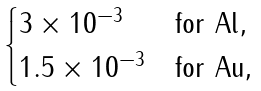Convert formula to latex. <formula><loc_0><loc_0><loc_500><loc_500>\begin{cases} 3 \times 1 0 ^ { - 3 } & \text {for Al} , \\ 1 . 5 \times 1 0 ^ { - 3 } & \text {for Au} , \end{cases}</formula> 